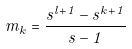Convert formula to latex. <formula><loc_0><loc_0><loc_500><loc_500>m _ { k } = \frac { s ^ { l + 1 } - s ^ { k + 1 } } { s - 1 }</formula> 